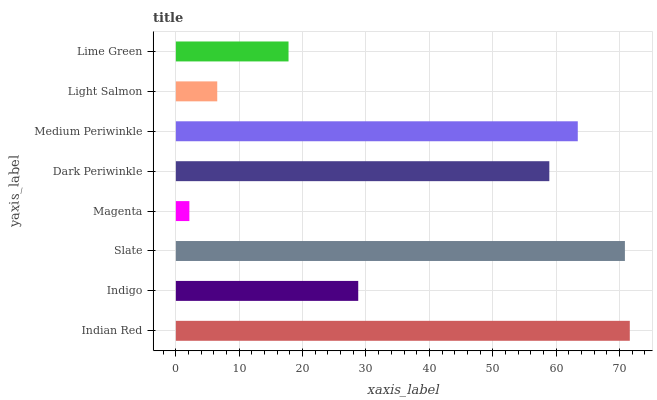Is Magenta the minimum?
Answer yes or no. Yes. Is Indian Red the maximum?
Answer yes or no. Yes. Is Indigo the minimum?
Answer yes or no. No. Is Indigo the maximum?
Answer yes or no. No. Is Indian Red greater than Indigo?
Answer yes or no. Yes. Is Indigo less than Indian Red?
Answer yes or no. Yes. Is Indigo greater than Indian Red?
Answer yes or no. No. Is Indian Red less than Indigo?
Answer yes or no. No. Is Dark Periwinkle the high median?
Answer yes or no. Yes. Is Indigo the low median?
Answer yes or no. Yes. Is Lime Green the high median?
Answer yes or no. No. Is Light Salmon the low median?
Answer yes or no. No. 